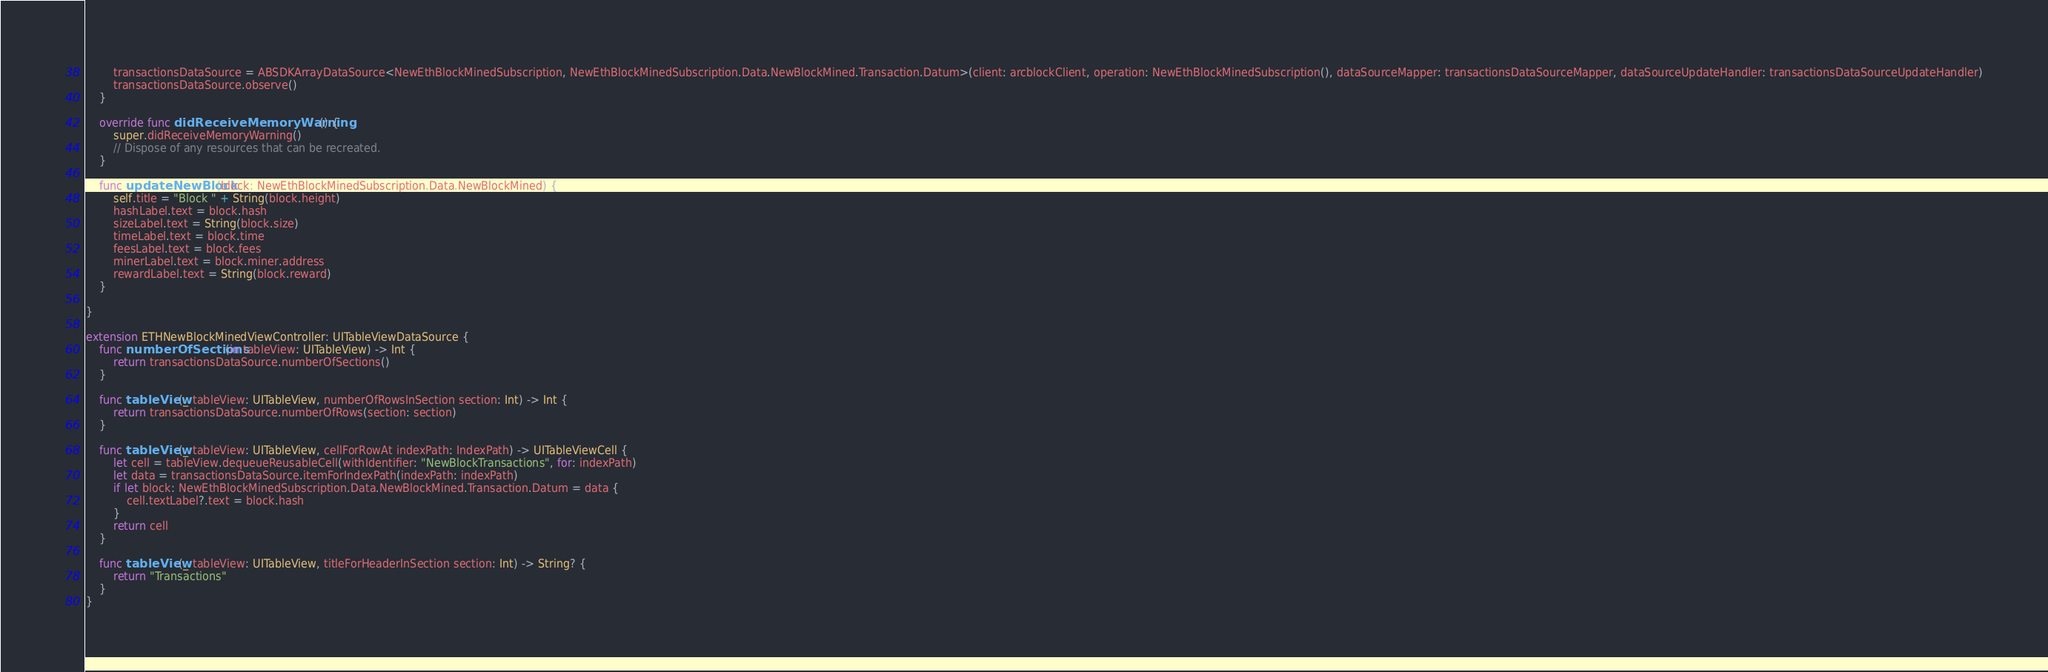Convert code to text. <code><loc_0><loc_0><loc_500><loc_500><_Swift_>        transactionsDataSource = ABSDKArrayDataSource<NewEthBlockMinedSubscription, NewEthBlockMinedSubscription.Data.NewBlockMined.Transaction.Datum>(client: arcblockClient, operation: NewEthBlockMinedSubscription(), dataSourceMapper: transactionsDataSourceMapper, dataSourceUpdateHandler: transactionsDataSourceUpdateHandler)
        transactionsDataSource.observe()
    }

    override func didReceiveMemoryWarning() {
        super.didReceiveMemoryWarning()
        // Dispose of any resources that can be recreated.
    }

    func updateNewBlock(block: NewEthBlockMinedSubscription.Data.NewBlockMined) {
        self.title = "Block " + String(block.height)
        hashLabel.text = block.hash
        sizeLabel.text = String(block.size)
        timeLabel.text = block.time
        feesLabel.text = block.fees
        minerLabel.text = block.miner.address
        rewardLabel.text = String(block.reward)
    }

}

extension ETHNewBlockMinedViewController: UITableViewDataSource {
    func numberOfSections(in tableView: UITableView) -> Int {
        return transactionsDataSource.numberOfSections()
    }

    func tableView(_ tableView: UITableView, numberOfRowsInSection section: Int) -> Int {
        return transactionsDataSource.numberOfRows(section: section)
    }

    func tableView(_ tableView: UITableView, cellForRowAt indexPath: IndexPath) -> UITableViewCell {
        let cell = tableView.dequeueReusableCell(withIdentifier: "NewBlockTransactions", for: indexPath)
        let data = transactionsDataSource.itemForIndexPath(indexPath: indexPath)
        if let block: NewEthBlockMinedSubscription.Data.NewBlockMined.Transaction.Datum = data {
            cell.textLabel?.text = block.hash
        }
        return cell
    }

    func tableView(_ tableView: UITableView, titleForHeaderInSection section: Int) -> String? {
        return "Transactions"
    }
}
</code> 